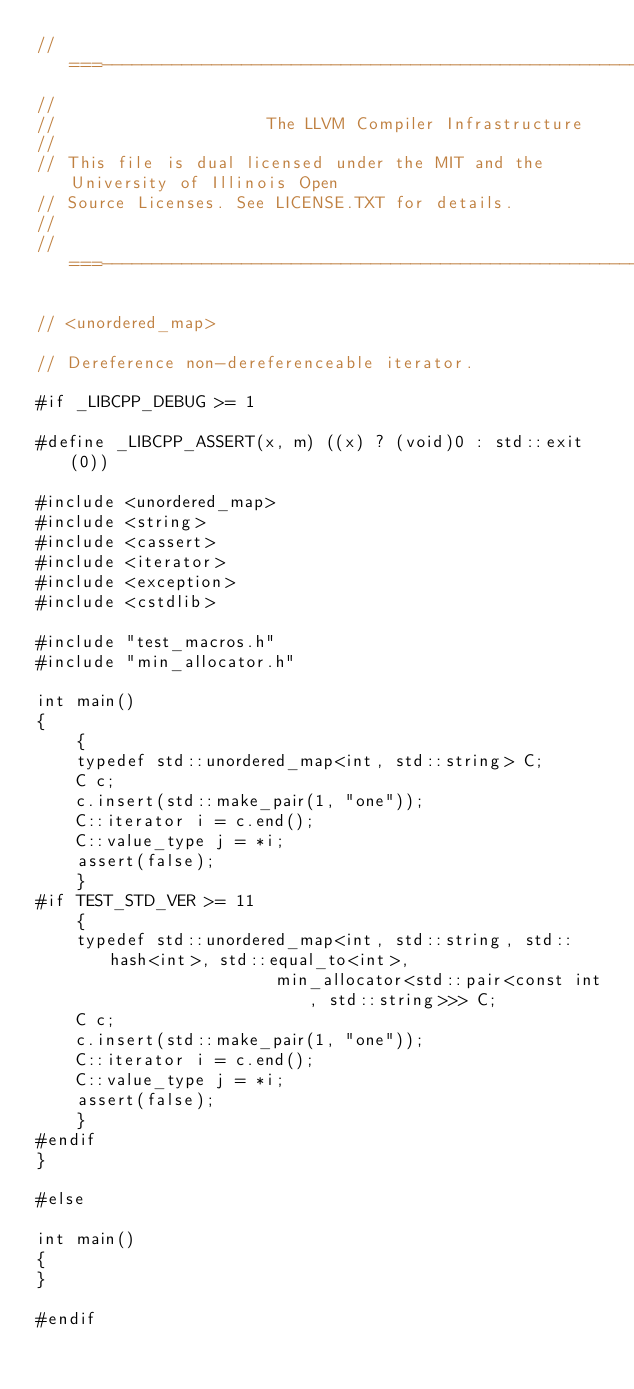Convert code to text. <code><loc_0><loc_0><loc_500><loc_500><_C++_>//===----------------------------------------------------------------------===//
//
//                     The LLVM Compiler Infrastructure
//
// This file is dual licensed under the MIT and the University of Illinois Open
// Source Licenses. See LICENSE.TXT for details.
//
//===----------------------------------------------------------------------===//

// <unordered_map>

// Dereference non-dereferenceable iterator.

#if _LIBCPP_DEBUG >= 1

#define _LIBCPP_ASSERT(x, m) ((x) ? (void)0 : std::exit(0))

#include <unordered_map>
#include <string>
#include <cassert>
#include <iterator>
#include <exception>
#include <cstdlib>

#include "test_macros.h"
#include "min_allocator.h"

int main()
{
    {
    typedef std::unordered_map<int, std::string> C;
    C c;
    c.insert(std::make_pair(1, "one"));
    C::iterator i = c.end();
    C::value_type j = *i;
    assert(false);
    }
#if TEST_STD_VER >= 11
    {
    typedef std::unordered_map<int, std::string, std::hash<int>, std::equal_to<int>,
                        min_allocator<std::pair<const int, std::string>>> C;
    C c;
    c.insert(std::make_pair(1, "one"));
    C::iterator i = c.end();
    C::value_type j = *i;
    assert(false);
    }
#endif
}

#else

int main()
{
}

#endif
</code> 